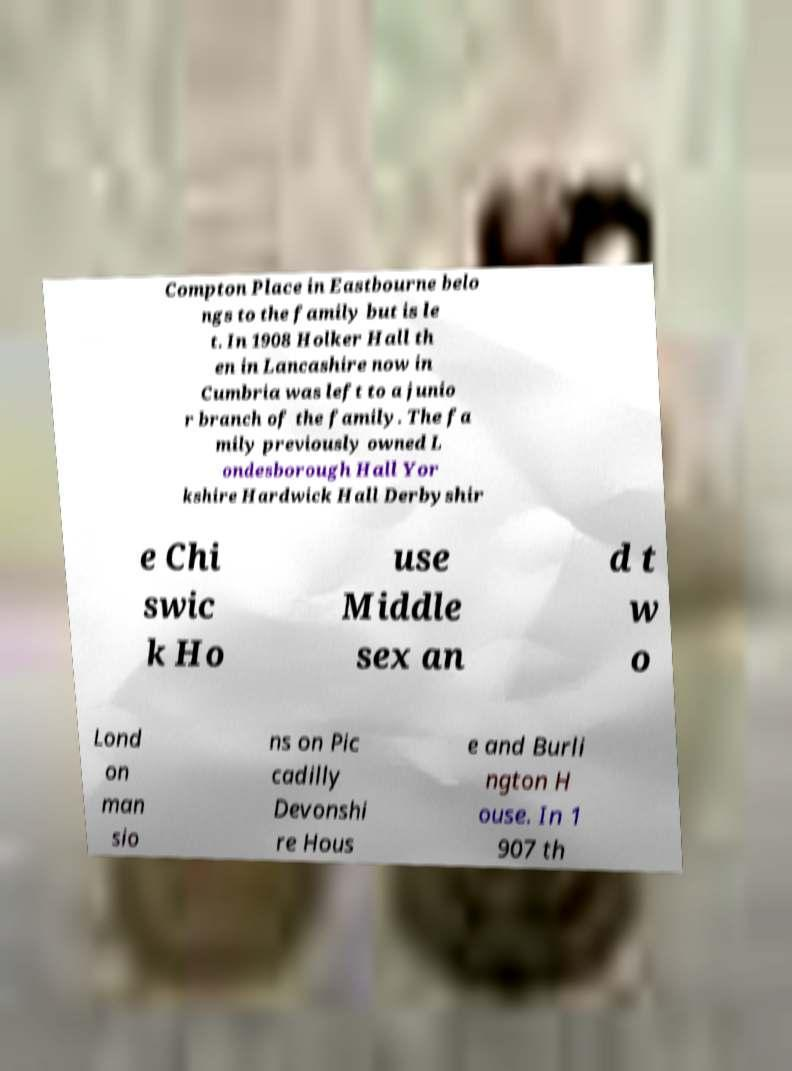For documentation purposes, I need the text within this image transcribed. Could you provide that? Compton Place in Eastbourne belo ngs to the family but is le t. In 1908 Holker Hall th en in Lancashire now in Cumbria was left to a junio r branch of the family. The fa mily previously owned L ondesborough Hall Yor kshire Hardwick Hall Derbyshir e Chi swic k Ho use Middle sex an d t w o Lond on man sio ns on Pic cadilly Devonshi re Hous e and Burli ngton H ouse. In 1 907 th 